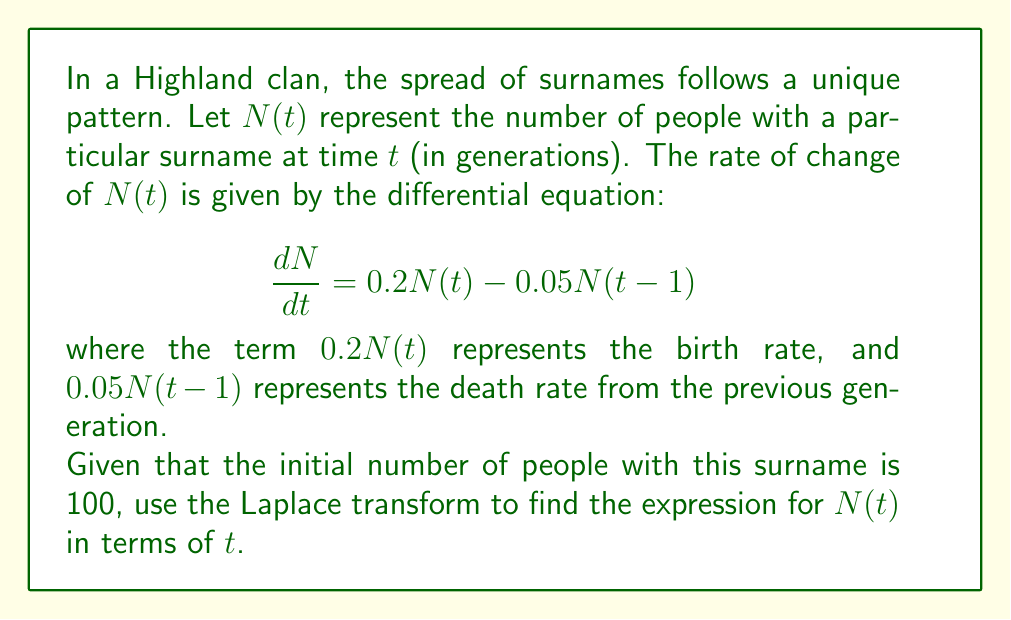Could you help me with this problem? Let's solve this step-by-step using the Laplace transform:

1) First, let's take the Laplace transform of both sides of the equation:

   $\mathcal{L}\{\frac{dN}{dt}\} = \mathcal{L}\{0.2N(t) - 0.05N(t-1)\}$

2) Using the properties of Laplace transform:

   $s\mathcal{L}\{N(t)\} - N(0) = 0.2\mathcal{L}\{N(t)\} - 0.05e^{-s}\mathcal{L}\{N(t)\}$

3) Let $\mathcal{L}\{N(t)\} = X(s)$ and substitute $N(0) = 100$:

   $sX(s) - 100 = 0.2X(s) - 0.05e^{-s}X(s)$

4) Rearranging the equation:

   $X(s)(s - 0.2 + 0.05e^{-s}) = 100$

5) Solving for $X(s)$:

   $X(s) = \frac{100}{s - 0.2 + 0.05e^{-s}}$

6) To find $N(t)$, we need to take the inverse Laplace transform of $X(s)$. However, this is a complex function and doesn't have a simple inverse transform.

7) We can approximate the solution using the Taylor series expansion of $e^{-s}$:

   $e^{-s} \approx 1 - s + \frac{s^2}{2} - \frac{s^3}{6} + ...$

8) Substituting this into our expression for $X(s)$ and keeping only the first two terms:

   $X(s) \approx \frac{100}{s - 0.2 + 0.05(1 - s)} = \frac{100}{0.95s - 0.15}$

9) This simplified form has a known inverse Laplace transform:

   $N(t) \approx 100e^{\frac{0.15}{0.95}t} = 100e^{0.1579t}$

Therefore, the approximate expression for $N(t)$ in terms of $t$ is $100e^{0.1579t}$.
Answer: $N(t) \approx 100e^{0.1579t}$ 